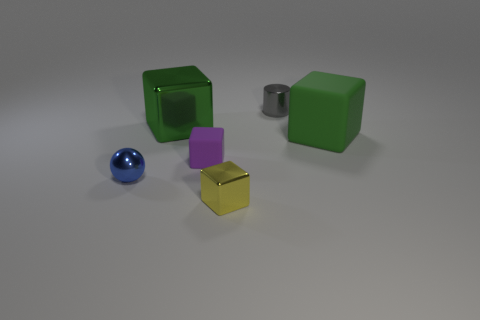What could be the purpose of the arrangement of these objects? The arrangement may serve various purposes. It might be an artistic composition meant to showcase the interplay of light and shadow on different surfaces, or it could be a setup for a physics demonstration about reflections and materials. Another possibility is that it's a 3D rendering used for graphic design or visual effects training, where objects of different shapes and materials are used for practice. 